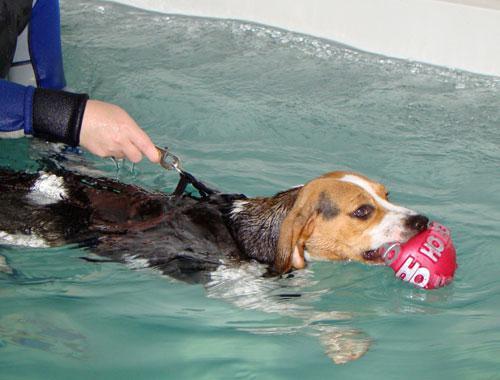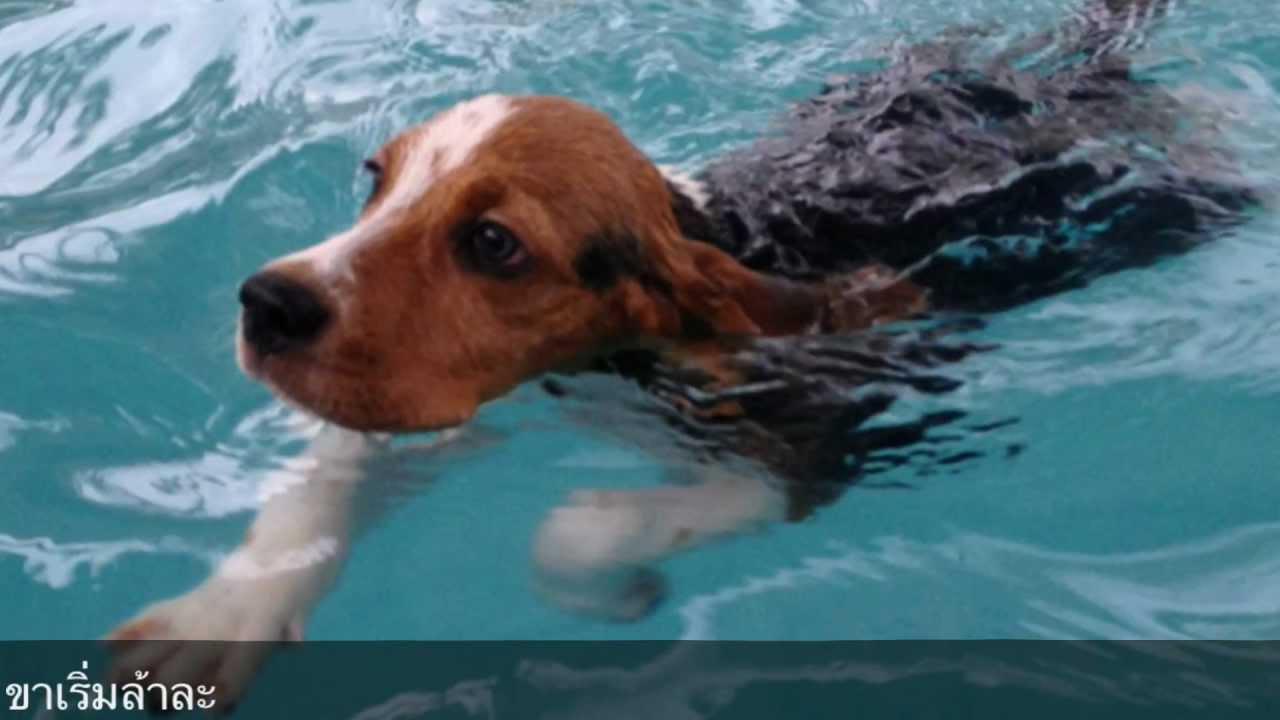The first image is the image on the left, the second image is the image on the right. Assess this claim about the two images: "The dog on the right image has its head under water.". Correct or not? Answer yes or no. No. The first image is the image on the left, the second image is the image on the right. Examine the images to the left and right. Is the description "a dog is swimming with a toy in its mouth" accurate? Answer yes or no. Yes. 